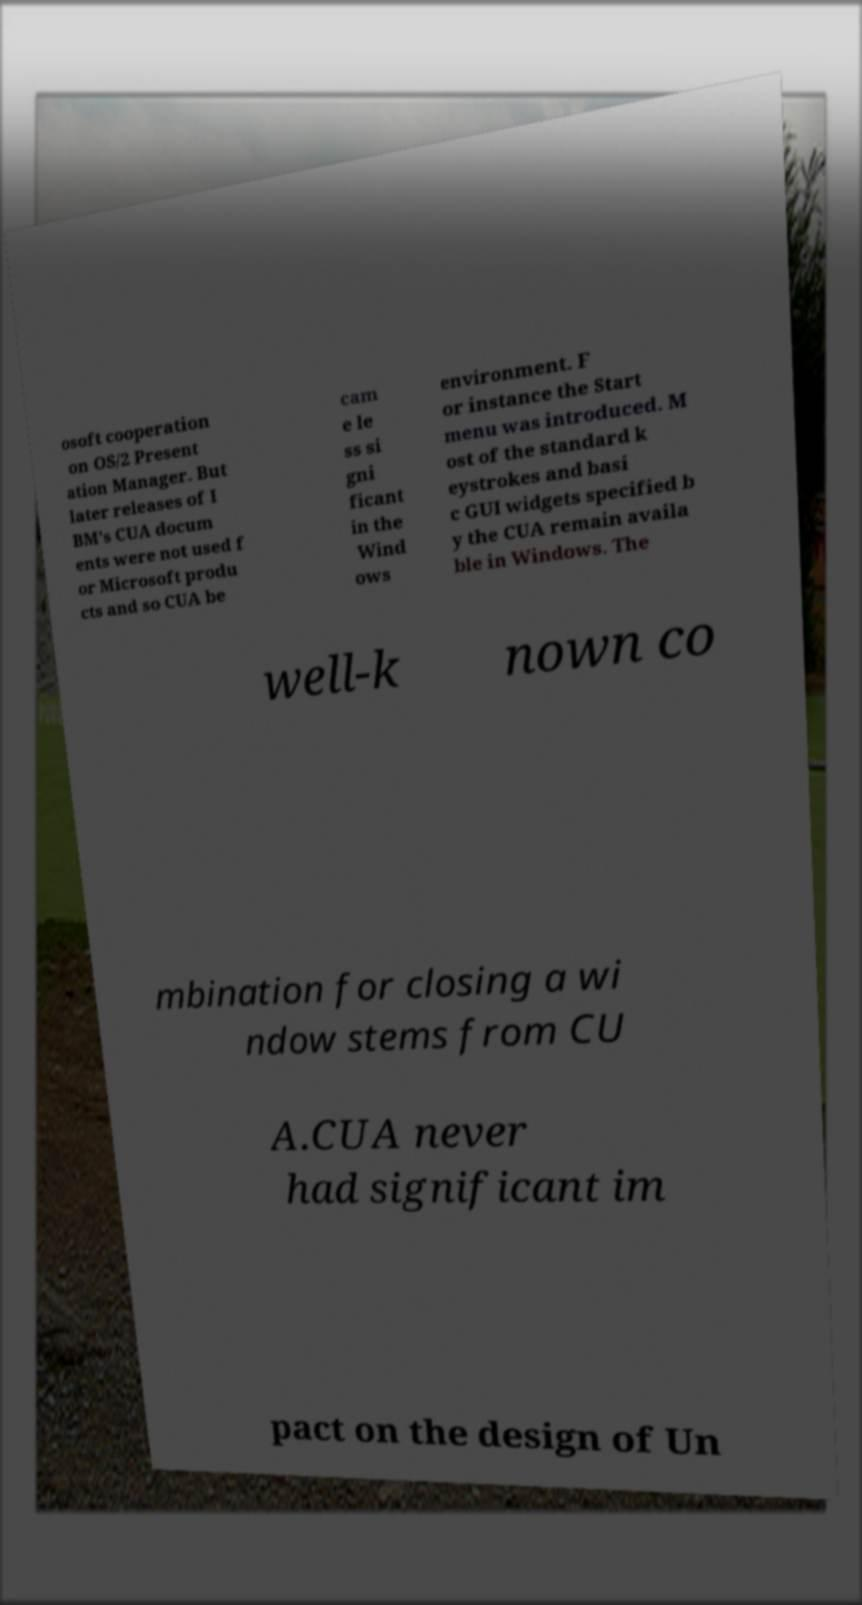There's text embedded in this image that I need extracted. Can you transcribe it verbatim? osoft cooperation on OS/2 Present ation Manager. But later releases of I BM's CUA docum ents were not used f or Microsoft produ cts and so CUA be cam e le ss si gni ficant in the Wind ows environment. F or instance the Start menu was introduced. M ost of the standard k eystrokes and basi c GUI widgets specified b y the CUA remain availa ble in Windows. The well-k nown co mbination for closing a wi ndow stems from CU A.CUA never had significant im pact on the design of Un 